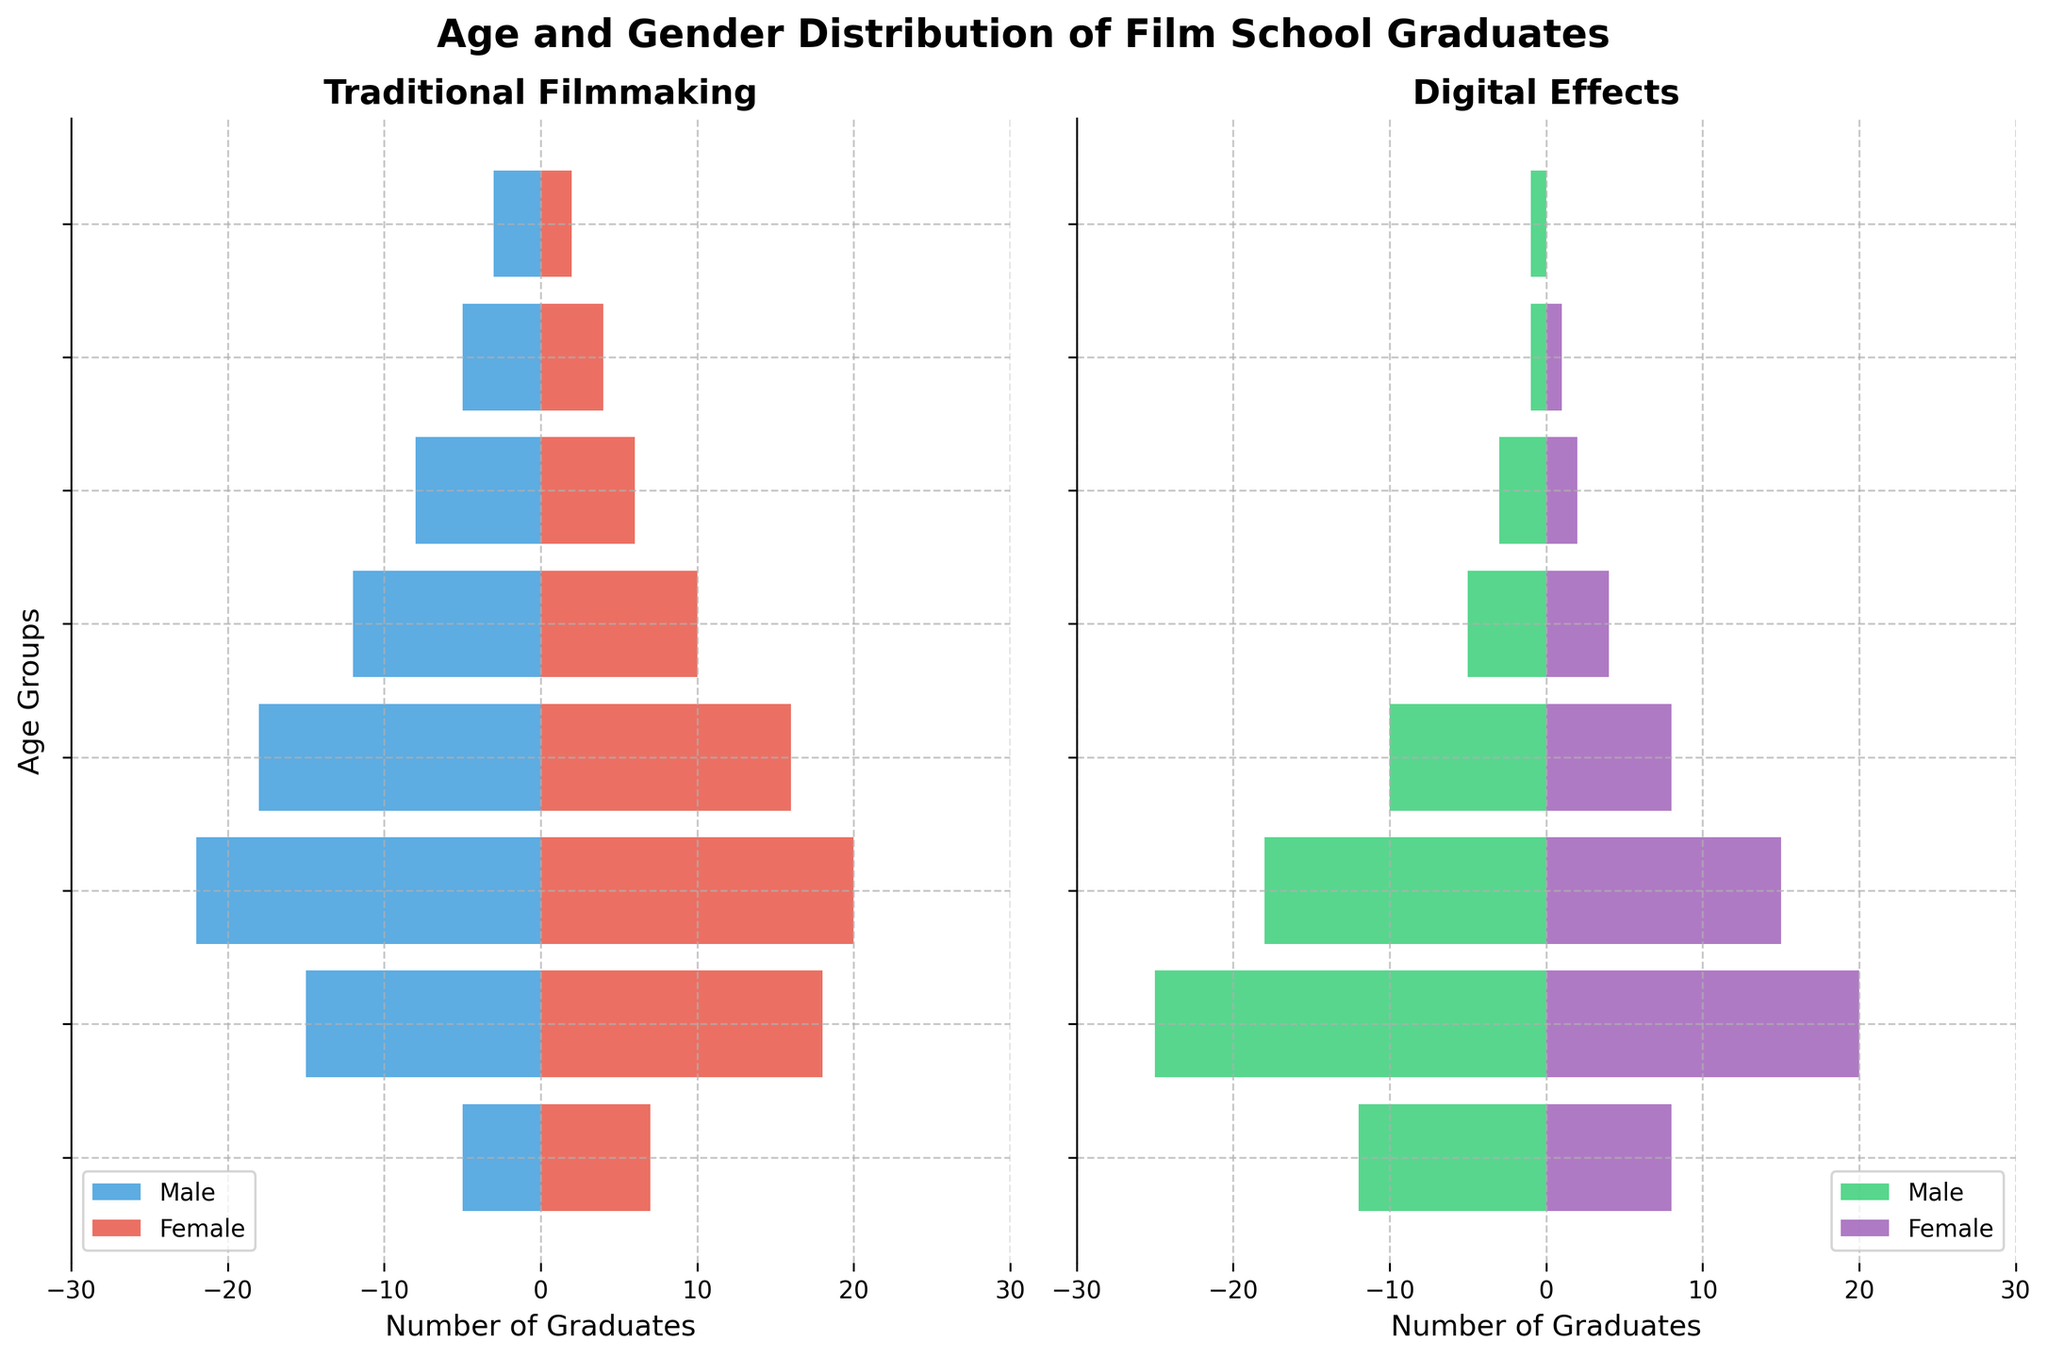Which gender has the most graduates in the 23-27 age group for Digital Effects? Look at the right side of the plot where the bars for Digital Effects are. Compare the lengths of the bars (green for males and purple for females). The green bar is longer indicating more graduates.
Answer: Male How many total graduates are there in the traditional filmmaking category for the 18-22 age group? Look at the left side of the plot where the bars for Traditional Filmmaking are. Add the lengths of the blue and red bars in the 18-22 age group.
Answer: 12 What is the difference in the number of female graduates between Traditional and Digital Effects in the 33-37 age group? Identify the lengths of the red bar on the left (Traditional) and the purple bar on the right (Digital) in the 33-37 age group. Subtract the lengths of the Digital Effects female graduates from the Traditional female graduates.
Answer: 8 Which age group has the highest number of male graduates in Traditional Filmmaking? Look at the length of blue bars on the left side of the plot. The 28-32 age group has the longest blue bar, indicating the highest number of male graduates.
Answer: 28-32 How many total graduates are there in the 33-37 age group combining both Traditional and Digital Effects? Add the number of graduates in both categories (Traditional and Digital) for the 33-37 age group. Traditional Male (18) + Traditional Female (16) + Digital Male (10) + Digital Female (8).
Answer: 52 Is there any age group where the number of female graduates in Digital Effects is higher than the number of male graduates? Compare the lengths of the green (male) and purple (female) bars in each age group on the right side of the plot. In all cases, the green bars are longer than the purple bars.
Answer: No What is the total number of male Digital Effects graduates in the 18-22 and 23-27 age groups combined? Look at the green bars on the right for the 18-22 and 23-27 age groups. Add the lengths of these bars together.
Answer: 37 Which category shows more gender parity in the 28-32 age group? Compare the length difference between the blue (male) and red (female) bars on the left (Traditional) and between the green (male) and purple (female) bars on the right (Digital). The red and blue bars are closer in length than the green and purple bars, indicating more parity in Traditional Filmmaking.
Answer: Traditional Filmmaking Are there more Digital Effects graduates or Traditional Filmmaking graduates in the 53+ age group? Sum the lengths of the male and female bars on the left (Traditional) and on the right (Digital) for the 53+ age group. Traditional has 5 graduates, and Digital has 1 graduate.
Answer: Traditional Filmmaking 